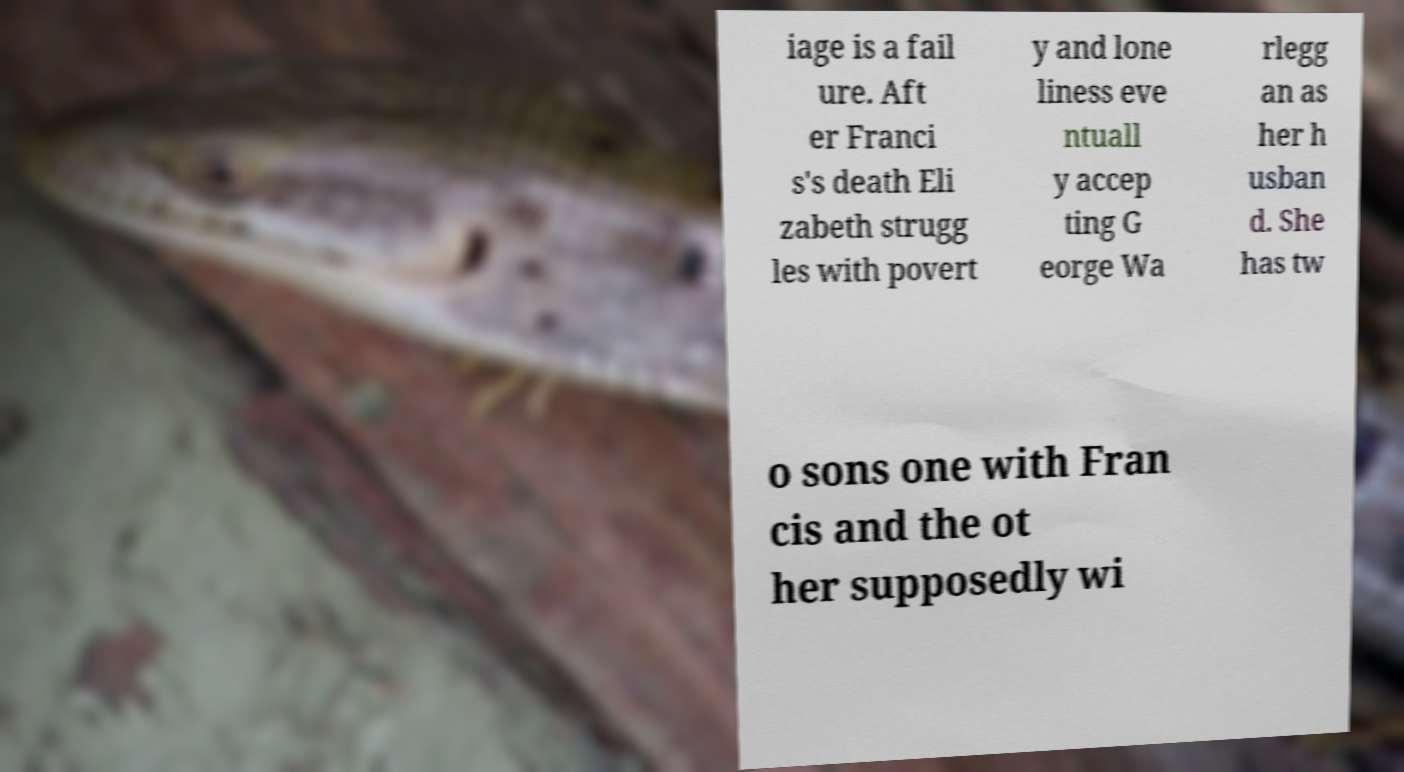There's text embedded in this image that I need extracted. Can you transcribe it verbatim? iage is a fail ure. Aft er Franci s's death Eli zabeth strugg les with povert y and lone liness eve ntuall y accep ting G eorge Wa rlegg an as her h usban d. She has tw o sons one with Fran cis and the ot her supposedly wi 